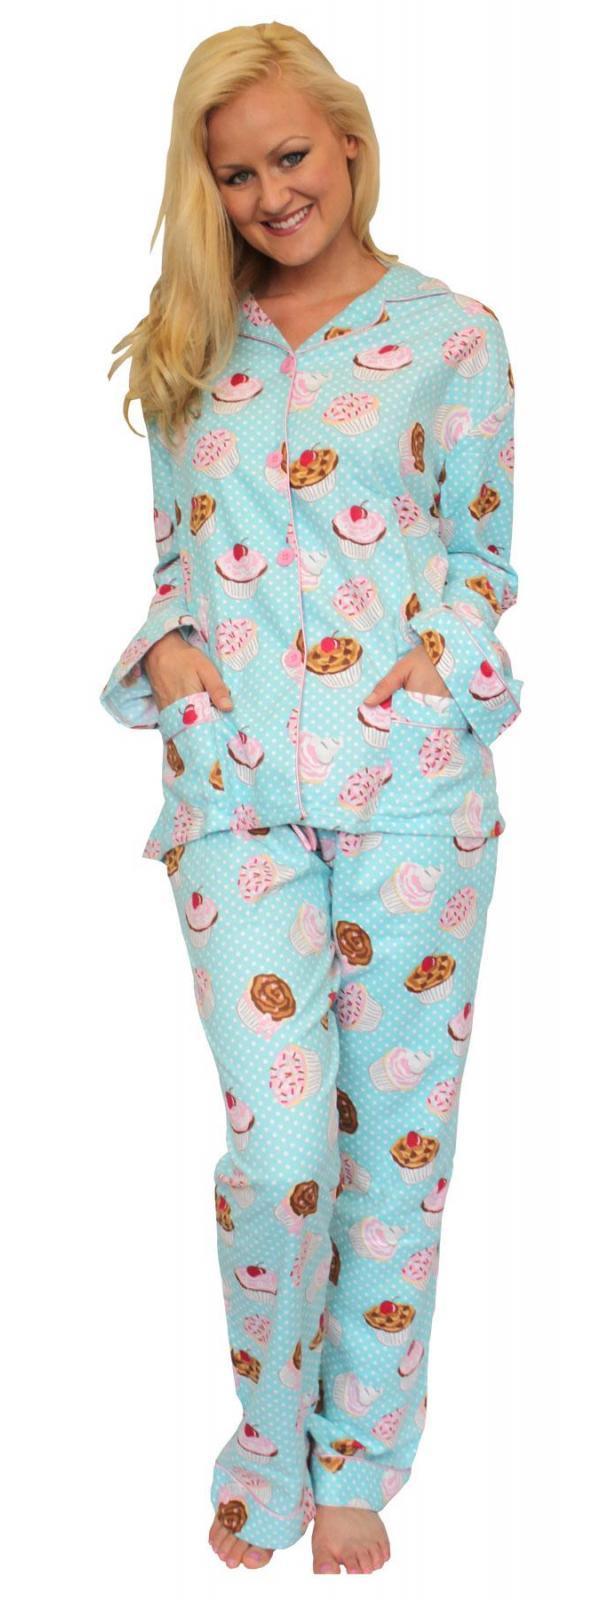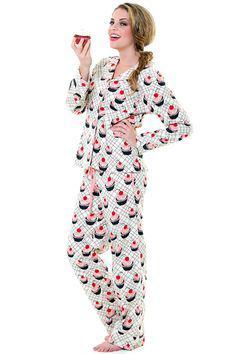The first image is the image on the left, the second image is the image on the right. Given the left and right images, does the statement "An image shows a brunette wearing printed blue pajamas." hold true? Answer yes or no. No. The first image is the image on the left, the second image is the image on the right. Considering the images on both sides, is "The woman in the right image has one hand on her waist in posing position." valid? Answer yes or no. Yes. 